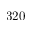Convert formula to latex. <formula><loc_0><loc_0><loc_500><loc_500>3 2 0</formula> 